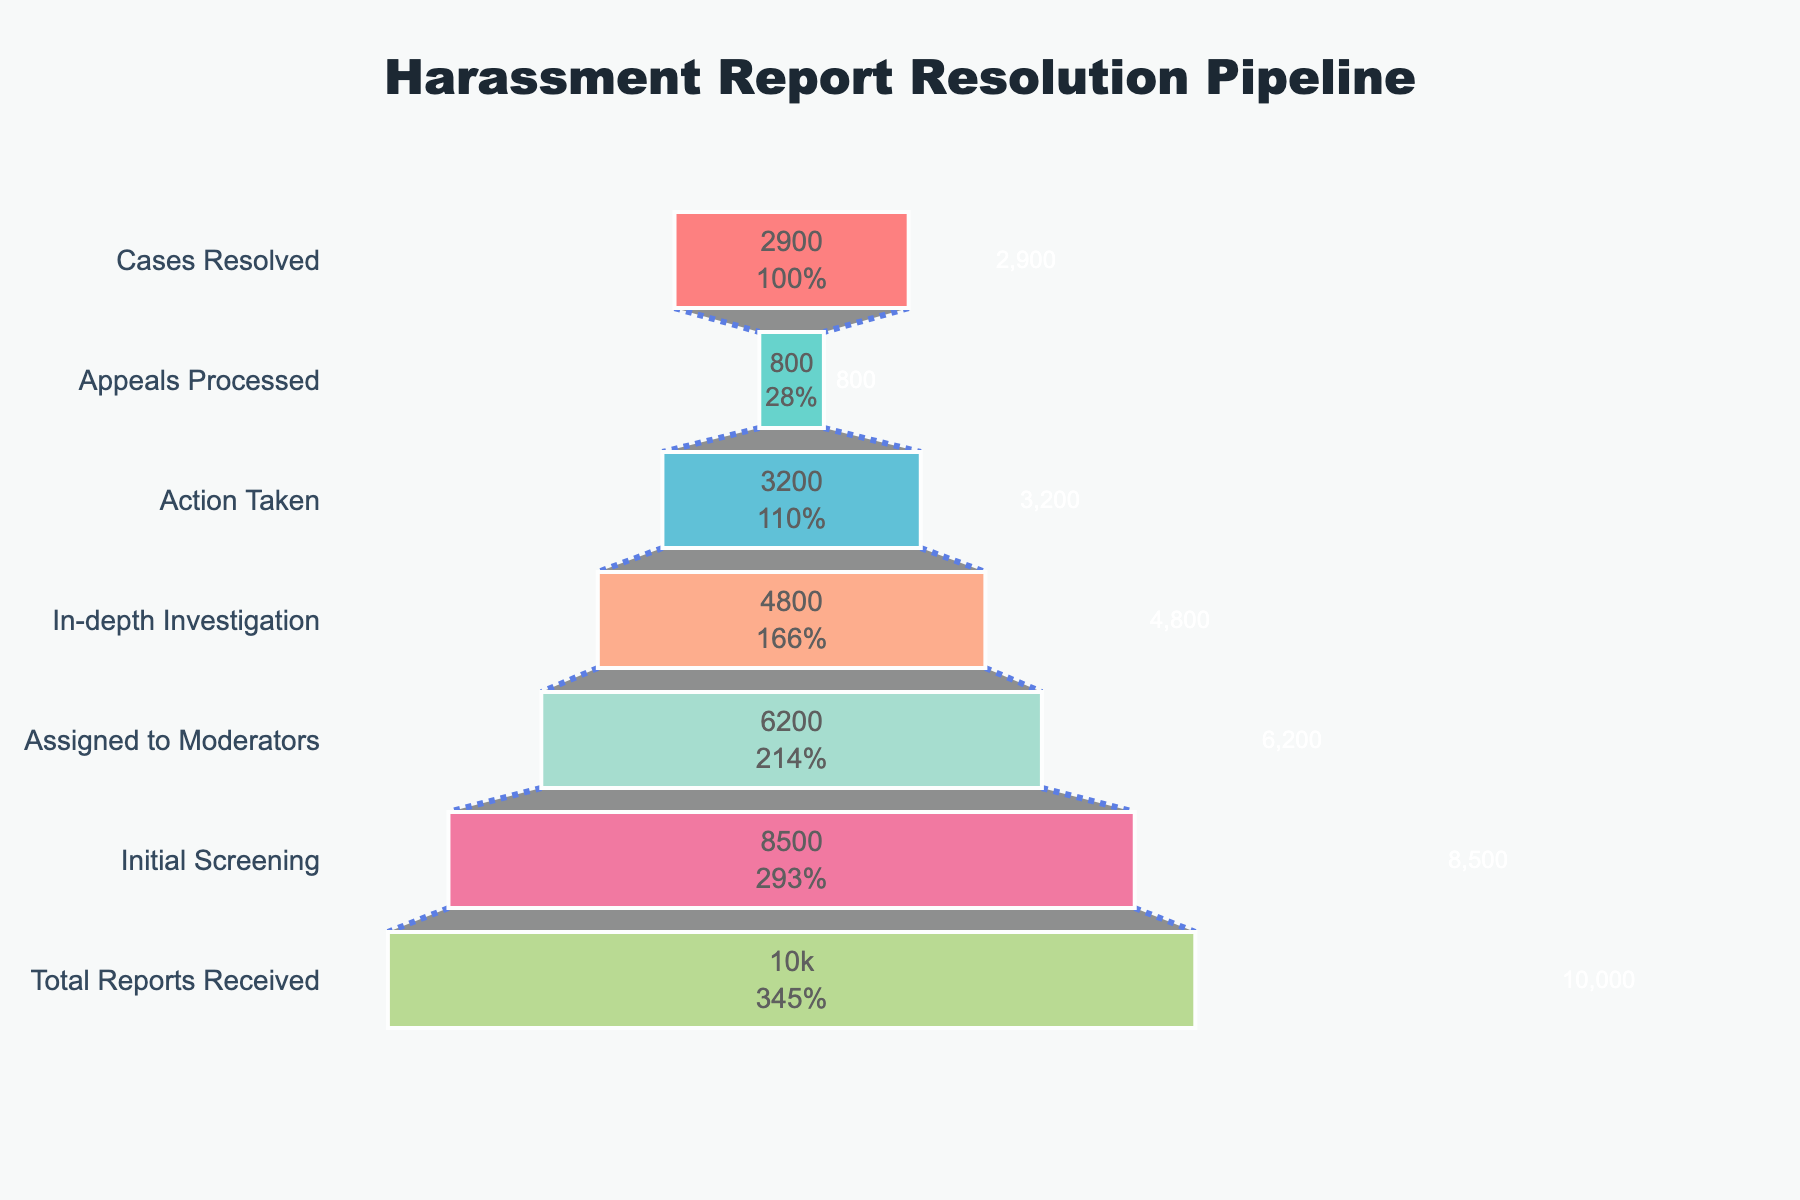What's the total number of harassment reports received? The funnel chart shows the number of cases in each stage. The top stage represents the total number of reports received.
Answer: 10,000 How many cases are resolved out of those assigned to moderators? Look at the number of cases in the "Assigned to Moderators" stage and "Cases Resolved" stage.
Answer: 2,900 out of 6,200 What percentage of cases make it through the initial screening? The chart shows 10,000 total reports and 8,500 passing the initial screening. Calculate: (8,500 / 10,000) * 100.
Answer: 85% Which stage shows the highest drop-off in case volume? Compare the differences in case volumes between consecutive stages in the funnel chart. The highest drop-off is between "Action Taken" (3,200) and "Appeals Processed" (800).
Answer: Action Taken to Appeals Processed What is the difference in case volume between initial screening and cases resolved? Subtract the number of cases in "Cases Resolved" from "Initial Screening." 8,500 - 2,900.
Answer: 5,600 What color is used for the "Total Reports Received"? The chart uses different colors for the stages. The color for "Total Reports Received" is the top segment of the funnel.
Answer: Red How many cases are in the appeals process? Find the number of cases listed for the "Appeals Processed" stage.
Answer: 800 What fraction of the total reports received resulted in action taken? Divide the number of cases in "Action Taken" by the "Total Reports Received." 3,200 / 10,000.
Answer: 0.32 How many more cases pass initial screening compared to those assigned to moderators? Subtract the number of cases assigned to moderators from those passing initial screening. 8,500 - 6,200.
Answer: 2,300 